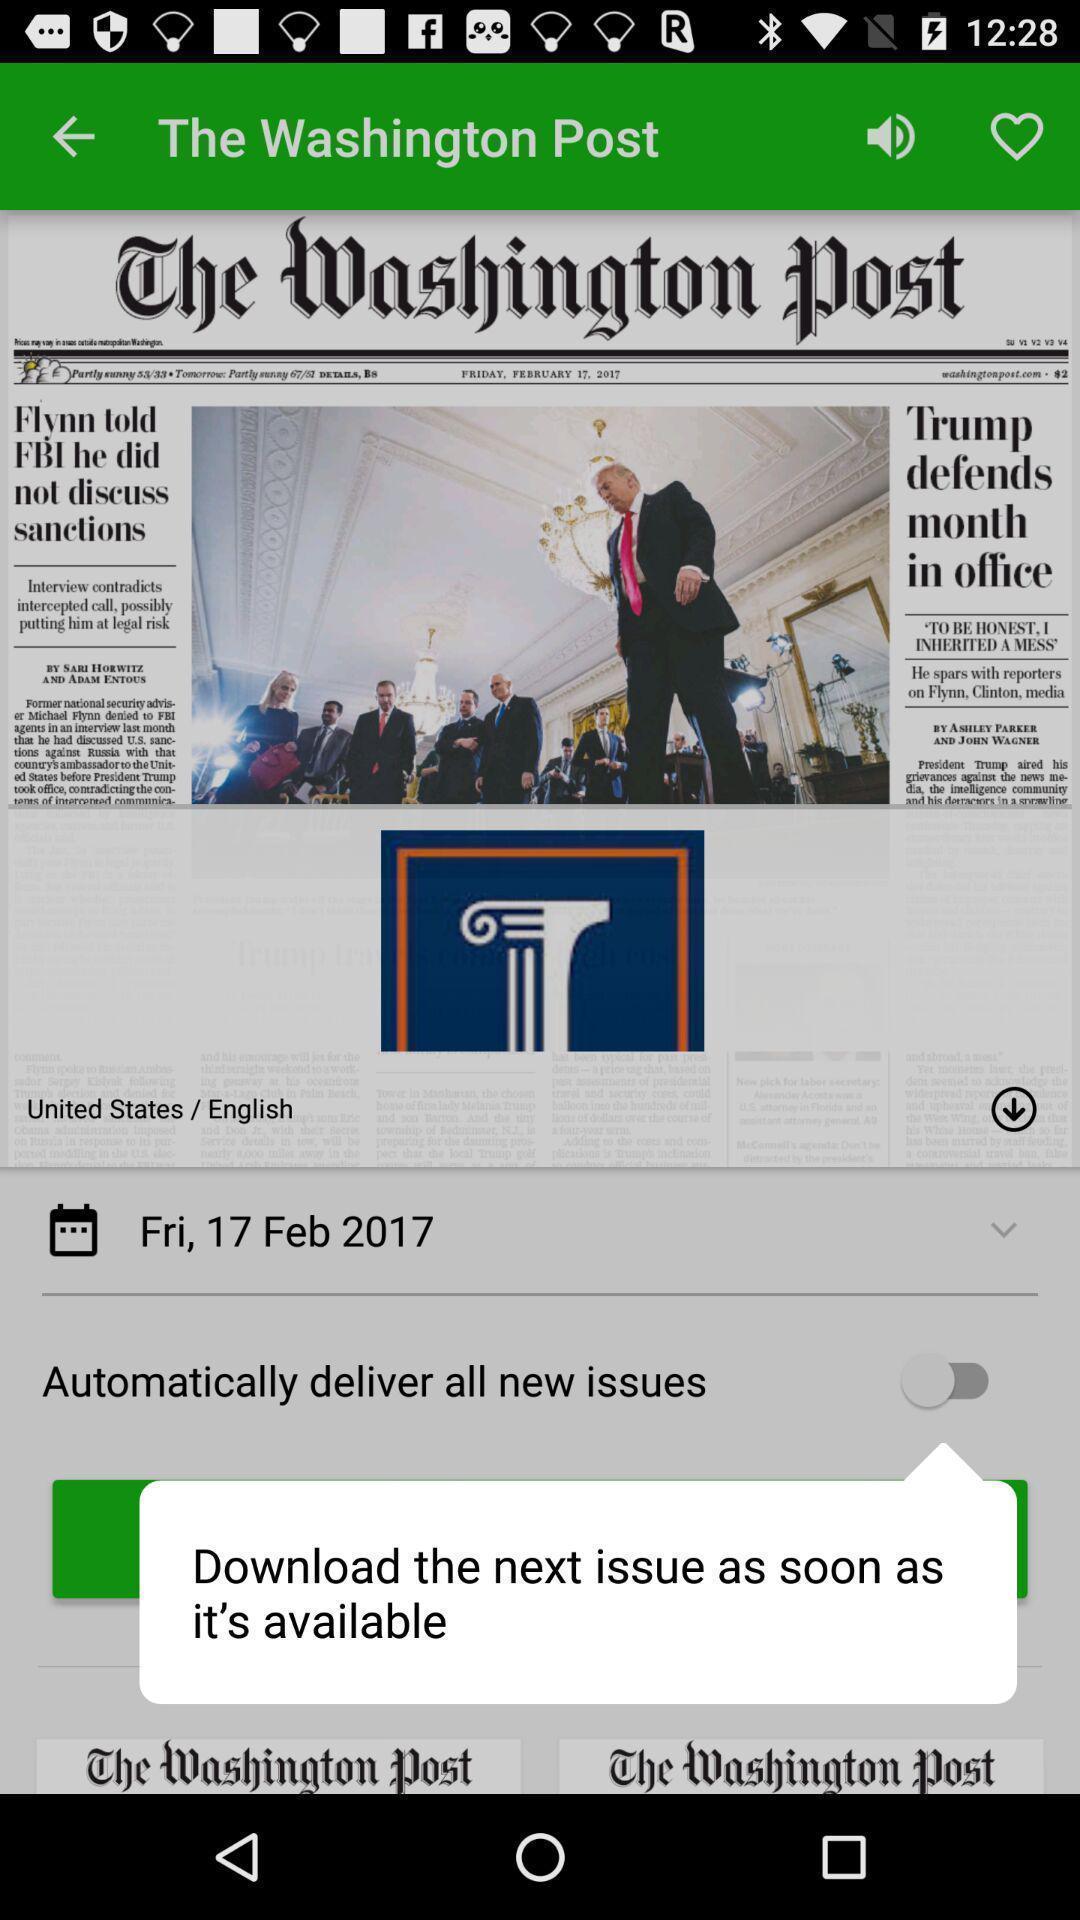Provide a detailed account of this screenshot. Pop-up showing the toggle icon to download. 